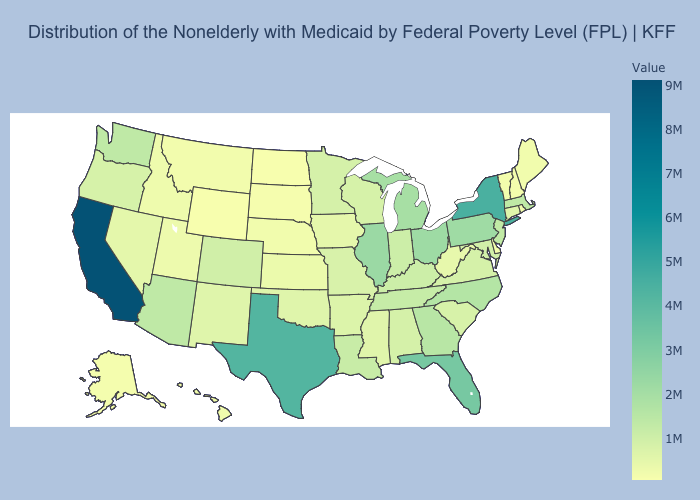Does Pennsylvania have a lower value than California?
Quick response, please. Yes. Is the legend a continuous bar?
Keep it brief. Yes. Does South Dakota have a lower value than California?
Keep it brief. Yes. Does California have the highest value in the USA?
Write a very short answer. Yes. 